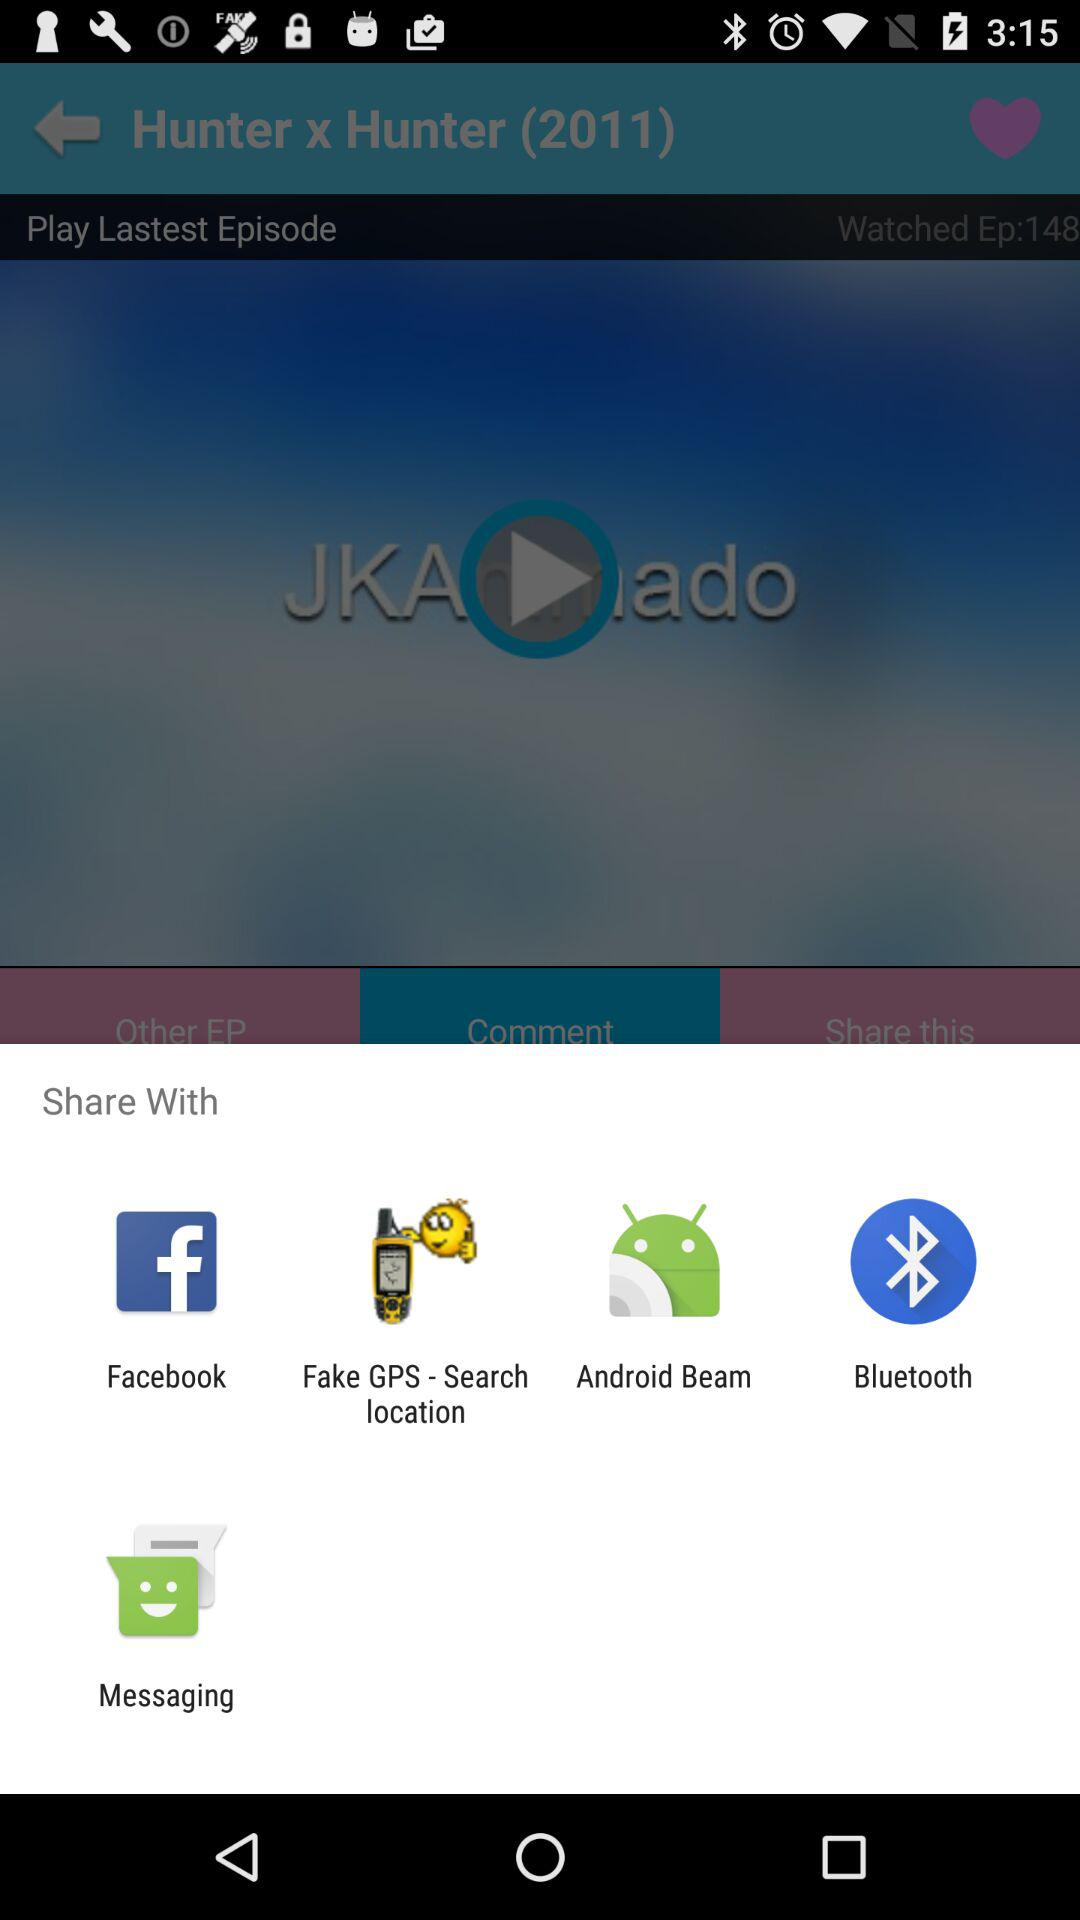What are the options we can share through? You can share through "Facebook", "Fake GPS - Search location", "Android Beam", "Bluetooth", and "Messaging". 